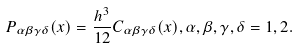<formula> <loc_0><loc_0><loc_500><loc_500>P _ { \alpha \beta \gamma \delta } ( x ) = \frac { h ^ { 3 } } { 1 2 } C _ { \alpha \beta \gamma \delta } ( x ) , \alpha , \beta , \gamma , \delta = 1 , 2 .</formula> 